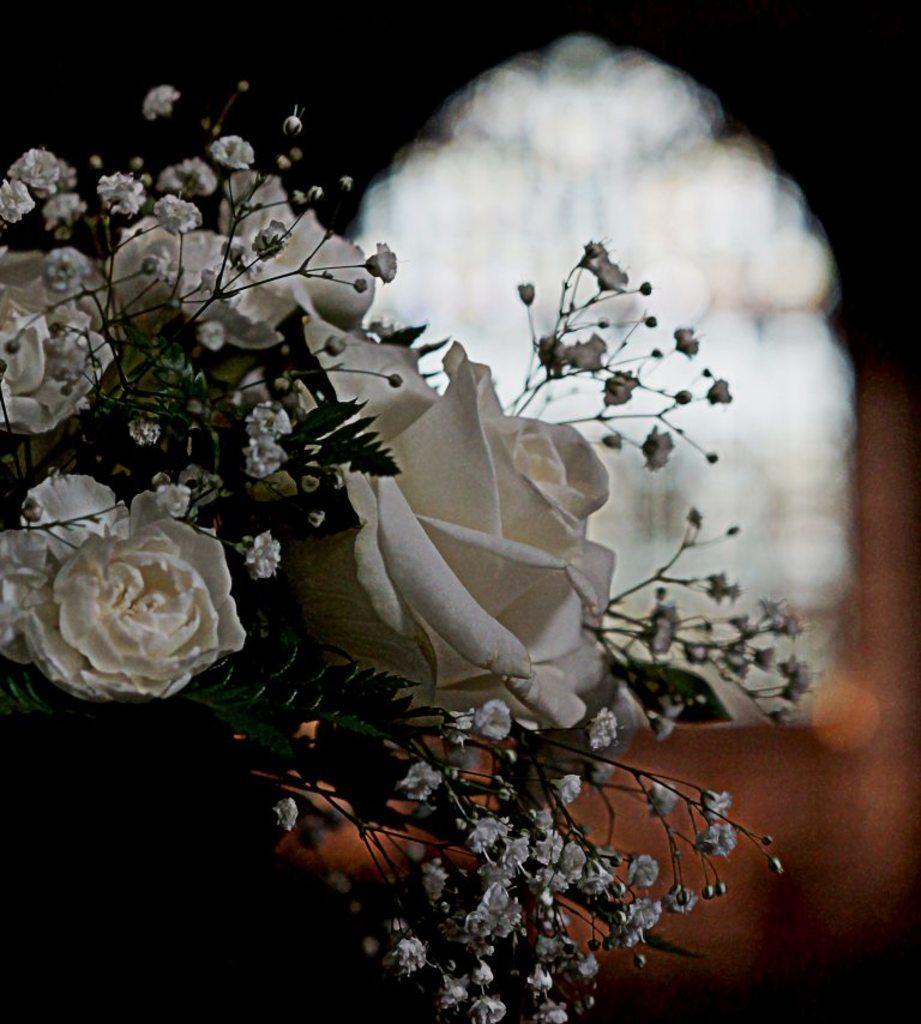Can you describe this image briefly? In this image I see flowers which are of white in color and I see the green leaves and it is blurred in the background. 